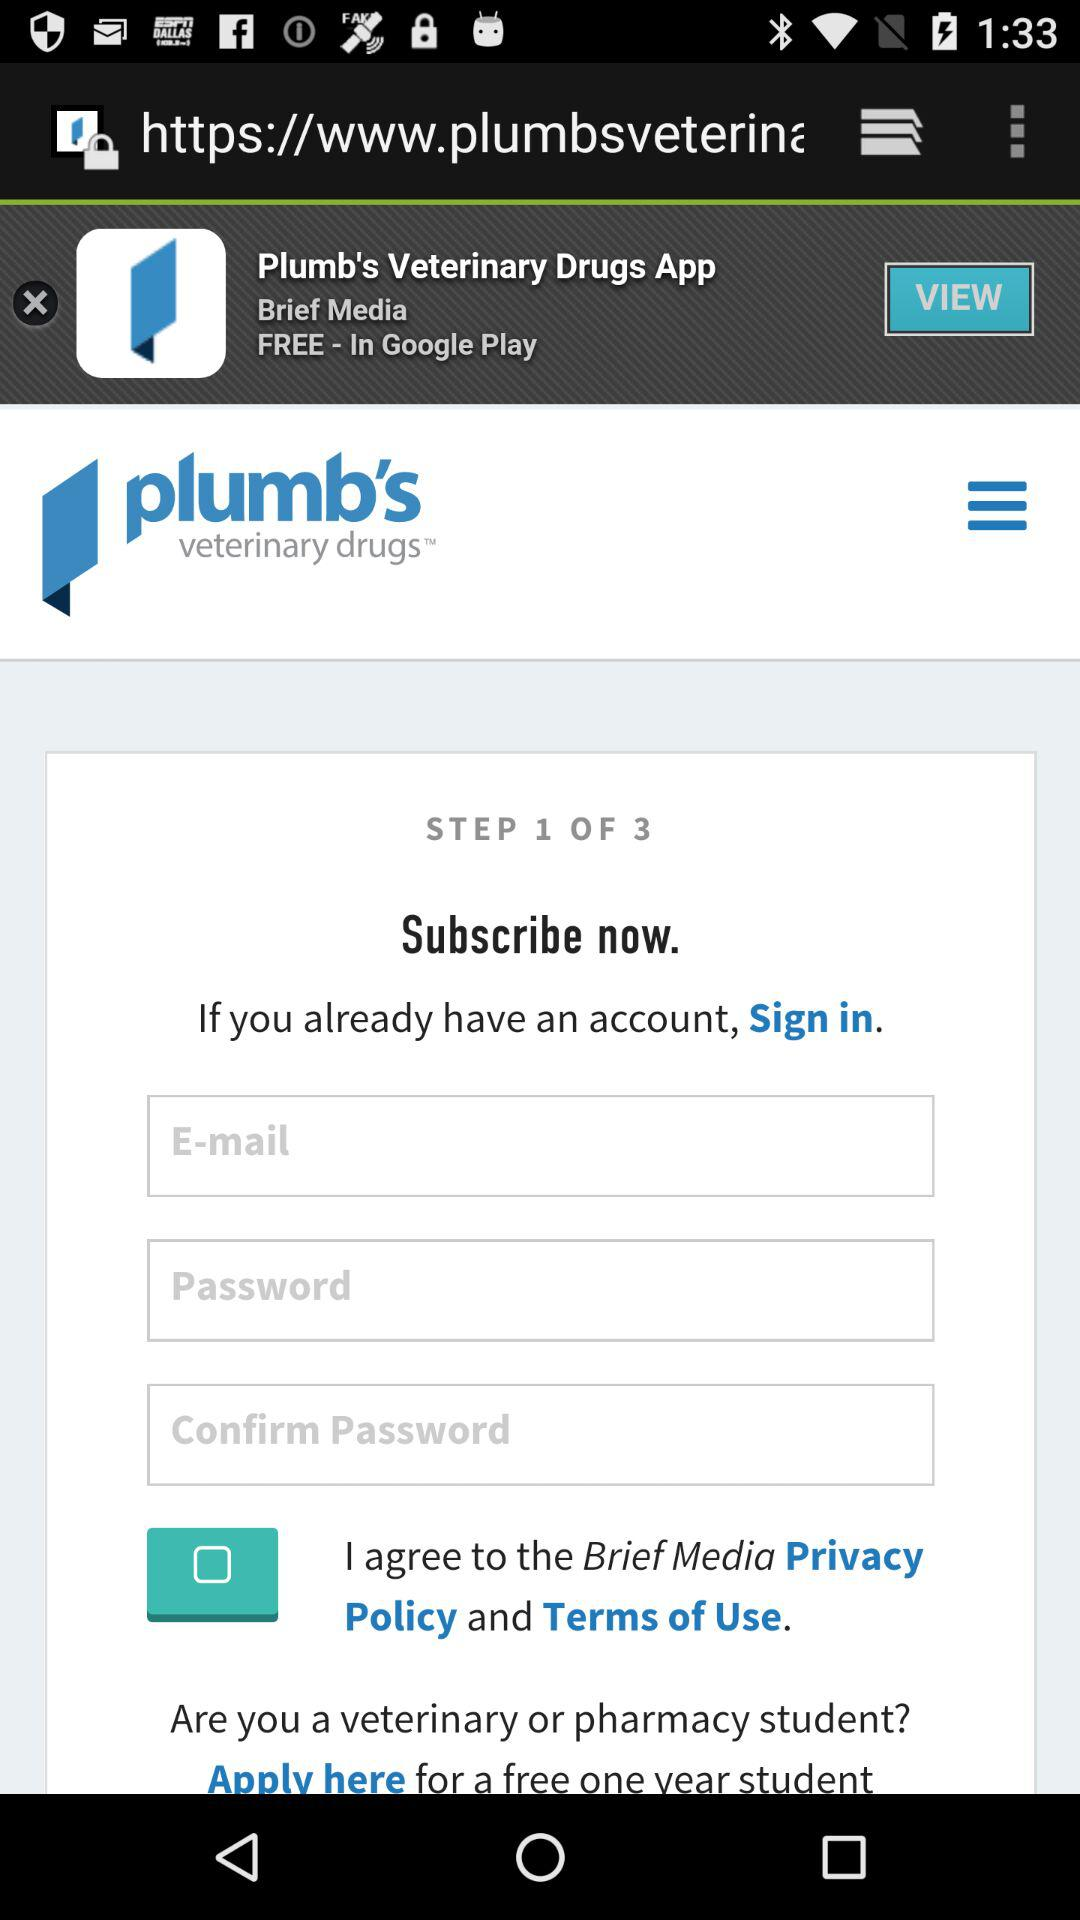What is the app name? The app name is "plumb's veterinary drug". 